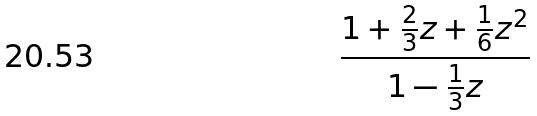<formula> <loc_0><loc_0><loc_500><loc_500>\frac { 1 + \frac { 2 } { 3 } z + \frac { 1 } { 6 } z ^ { 2 } } { 1 - \frac { 1 } { 3 } z }</formula> 